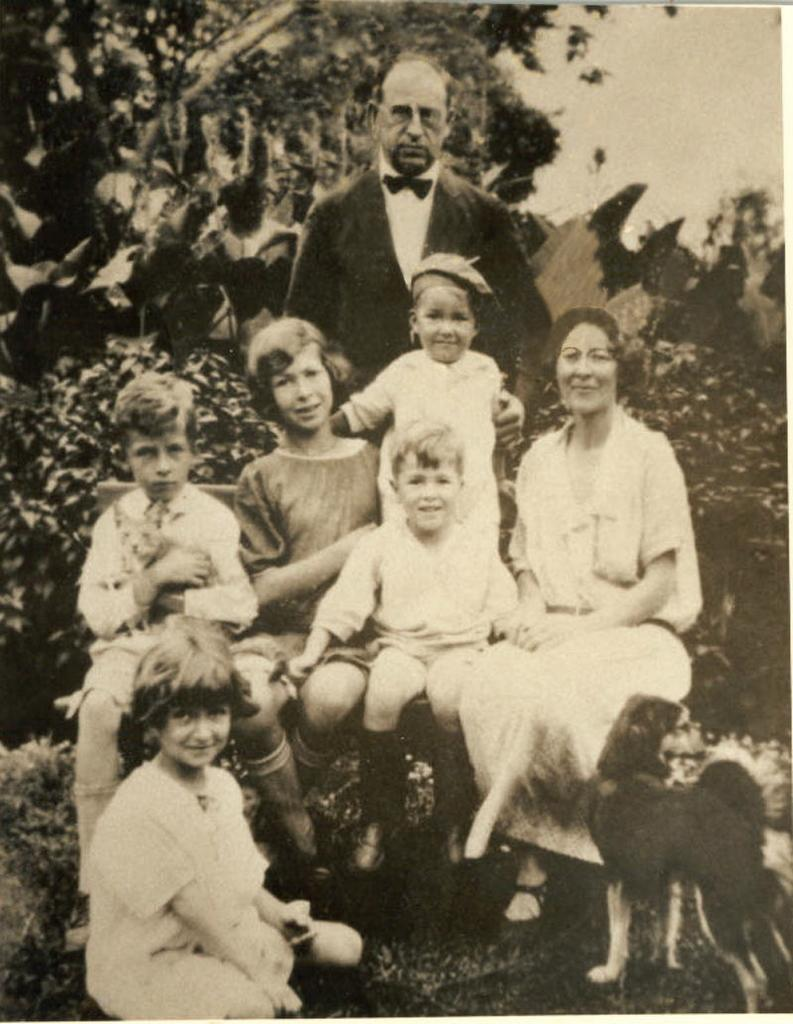How many people are in the image? There is a group of people in the image. What else can be seen in the image besides the people? There are trees and a dog in the image. What is the color scheme of the image? The image is in black and white. How does the fan help to sort the leaves in the image? There is no fan present in the image, and therefore no sorting or leaves can be observed. 